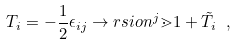Convert formula to latex. <formula><loc_0><loc_0><loc_500><loc_500>T _ { i } = - \frac { 1 } { 2 } \epsilon _ { i j } \to r s i o n ^ { j } \mathbb { m } { 1 } + { \tilde { T } } _ { i } \ ,</formula> 